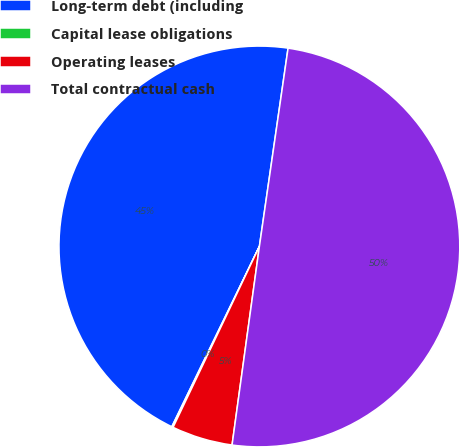<chart> <loc_0><loc_0><loc_500><loc_500><pie_chart><fcel>Long-term debt (including<fcel>Capital lease obligations<fcel>Operating leases<fcel>Total contractual cash<nl><fcel>45.09%<fcel>0.11%<fcel>4.91%<fcel>49.89%<nl></chart> 